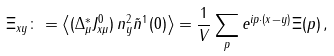<formula> <loc_0><loc_0><loc_500><loc_500>\Xi _ { x y } \colon = \left \langle ( \Delta ^ { * } _ { \mu } J ^ { 0 } _ { x \mu } ) \, n ^ { 2 } _ { y } \tilde { n } ^ { 1 } ( 0 ) \right \rangle = \frac { 1 } { V } \sum _ { p } e ^ { i p \cdot ( x - y ) } \Xi ( p ) \, ,</formula> 